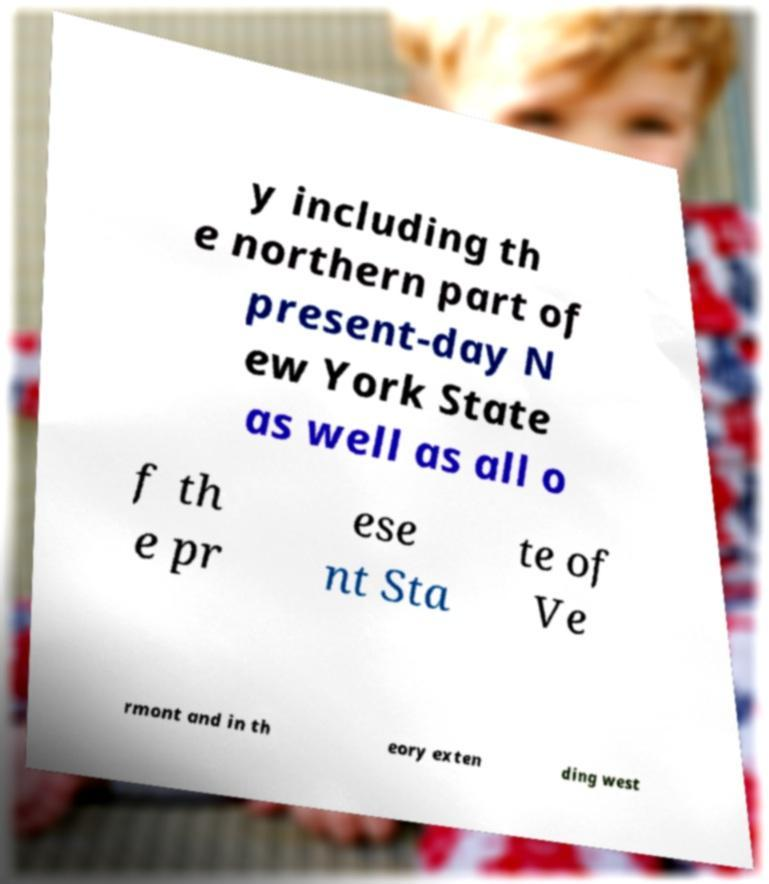Please identify and transcribe the text found in this image. y including th e northern part of present-day N ew York State as well as all o f th e pr ese nt Sta te of Ve rmont and in th eory exten ding west 